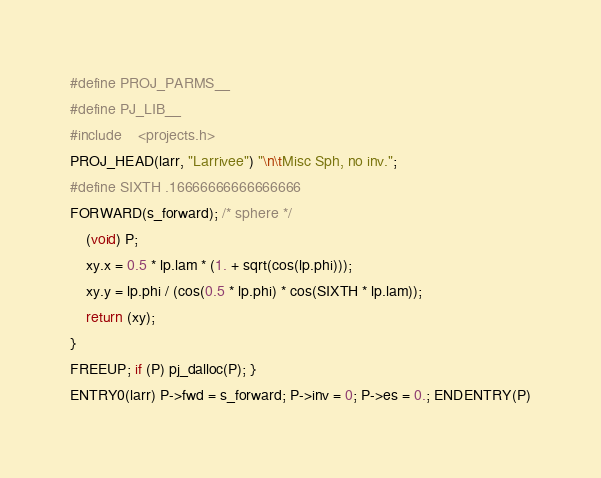Convert code to text. <code><loc_0><loc_0><loc_500><loc_500><_C_>#define PROJ_PARMS__
#define PJ_LIB__
#include	<projects.h>
PROJ_HEAD(larr, "Larrivee") "\n\tMisc Sph, no inv.";
#define SIXTH .16666666666666666
FORWARD(s_forward); /* sphere */
	(void) P;
	xy.x = 0.5 * lp.lam * (1. + sqrt(cos(lp.phi)));
	xy.y = lp.phi / (cos(0.5 * lp.phi) * cos(SIXTH * lp.lam));
	return (xy);
}
FREEUP; if (P) pj_dalloc(P); }
ENTRY0(larr) P->fwd = s_forward; P->inv = 0; P->es = 0.; ENDENTRY(P)
</code> 